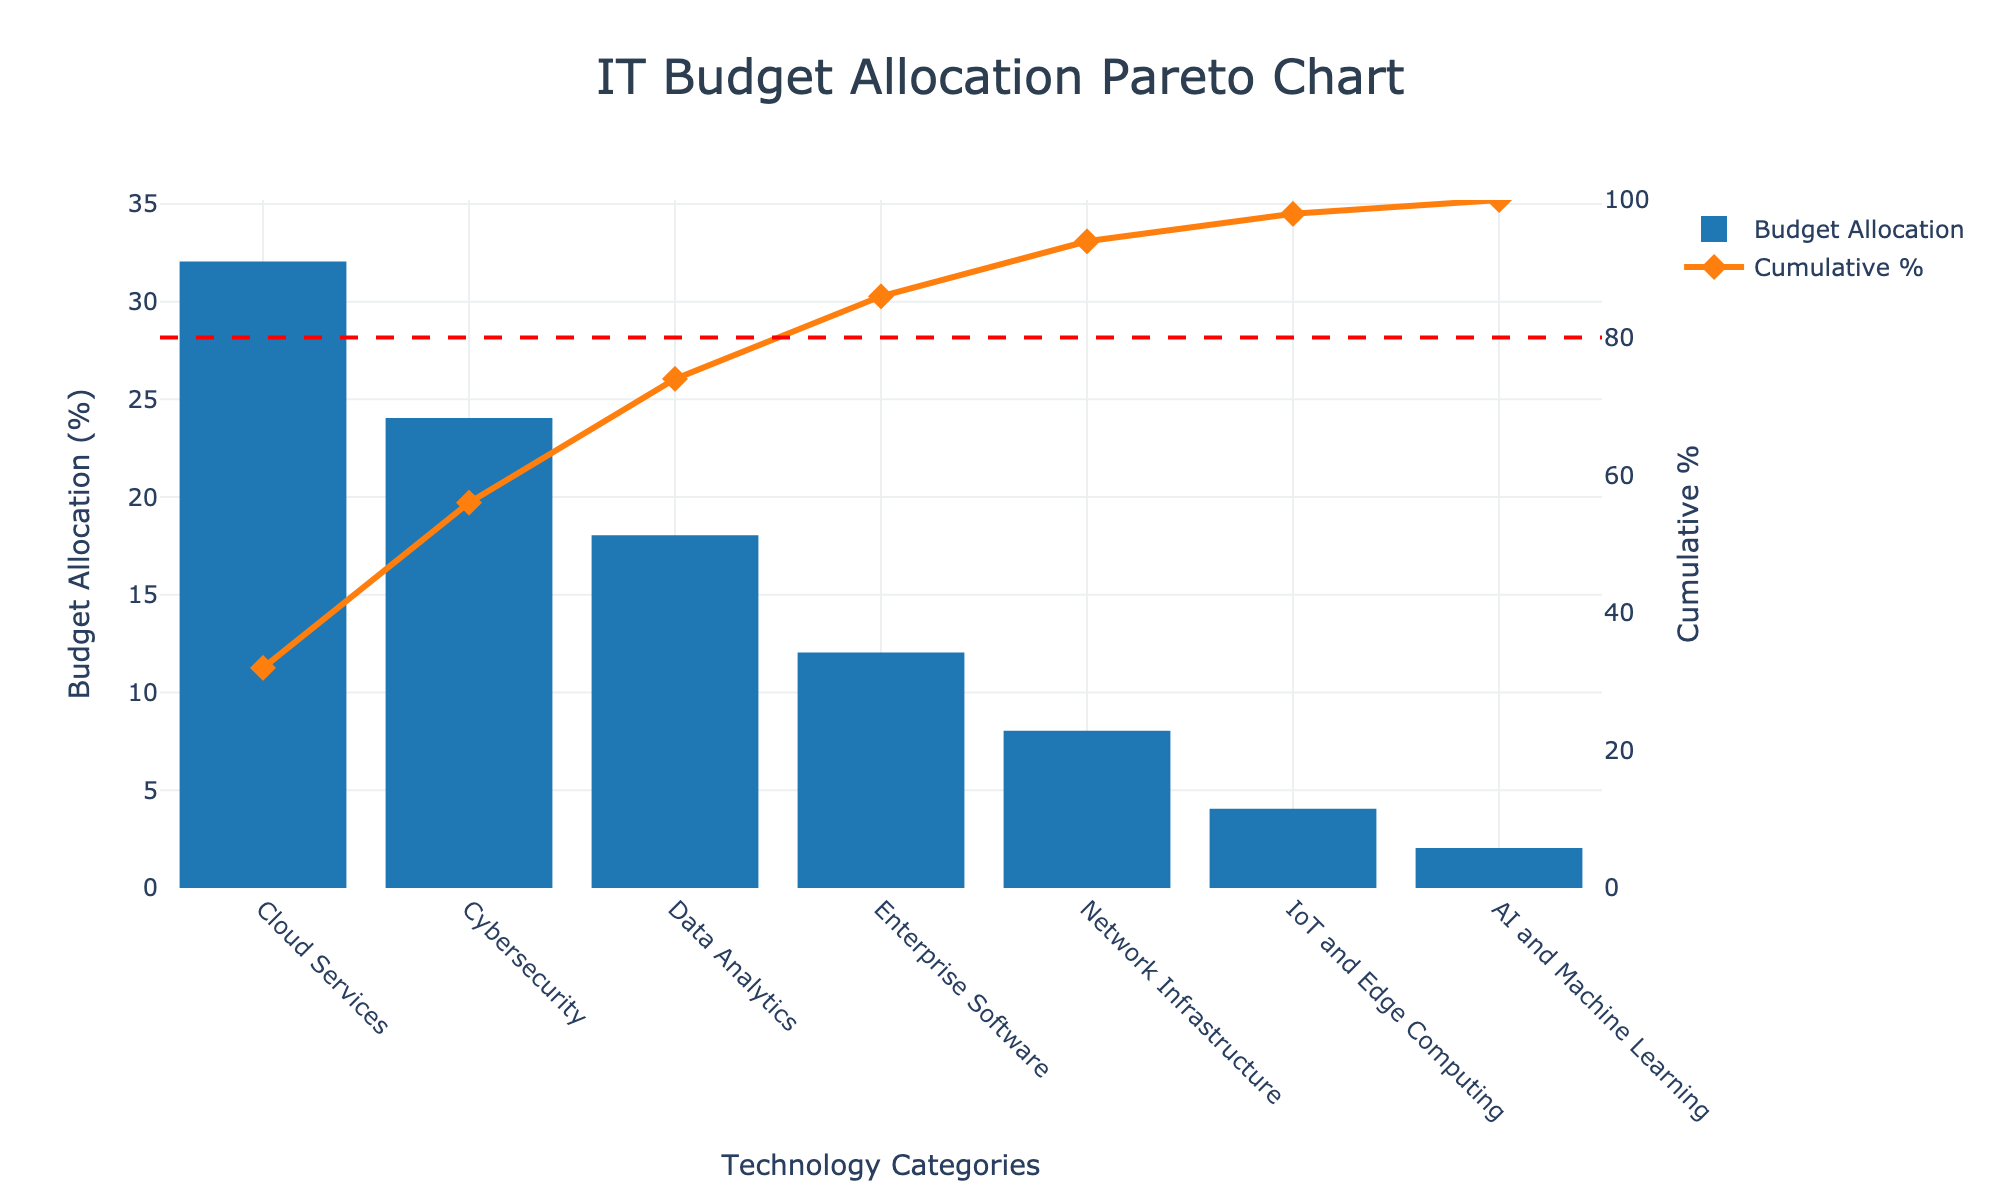What is the highest category in IT budget allocation? By examining the bars on the chart, the highest bar represents "Cloud Services" with a value of 32%.
Answer: Cloud Services What is the total percentage allocated to Cybersecurity and Data Analytics combined? Add the percentages for Cybersecurity (24%) and Data Analytics (18%): 24 + 18 = 42%.
Answer: 42% Which category is allocated the least budget? The smallest bar in the chart corresponds to "AI and Machine Learning" with a value of 2%.
Answer: AI and Machine Learning Compare the budget allocations between Network Infrastructure and IoT and Edge Computing. Which one has a higher allocation? Network Infrastructure (8%) has a higher allocation compared to IoT and Edge Computing (4%).
Answer: Network Infrastructure At what percentage does the cumulative budget exceed 80%? By following the cumulative percentage line, it exceeds the 80% mark between "Enterprise Software" (76%) and "Network Infrastructure" (84%).
Answer: Between Enterprise Software and Network Infrastructure What is the cumulative percentage after including Data Analytics? The cumulative percentage after including Data Analytics is 74%, as shown by the cumulative plot line.
Answer: 74% How many categories alone account for more than 60% of the total budget? By looking at the cumulative percentage line, "Cloud Services" and "Cybersecurity" together account for 32% + 24%, which is 56%. Including "Data Analytics" sums up to 74%, thus more than 60%. Therefore, it is the first three categories.
Answer: 3 What percentage of the IT budget is allocated to the top four categories combined? Summing up the top four categories: Cloud Services (32%), Cybersecurity (24%), Data Analytics (18%), and Enterprise Software (12%): 32 + 24 + 18 + 12 = 86%.
Answer: 86% Which categories fall below the 80-20 rule threshold? The categories below the 80% cumulative line are: Network Infrastructure (8%), IoT and Edge Computing (4%), and AI and Machine Learning (2%).
Answer: Network Infrastructure, IoT and Edge Computing, AI and Machine Learning If the total budget for IT is $1 million, how much money is allocated to Cybersecurity? Cybersecurity has 24% of the total budget. So, 24% of $1 million is 0.24 * 1,000,000 = $240,000.
Answer: $240,000 